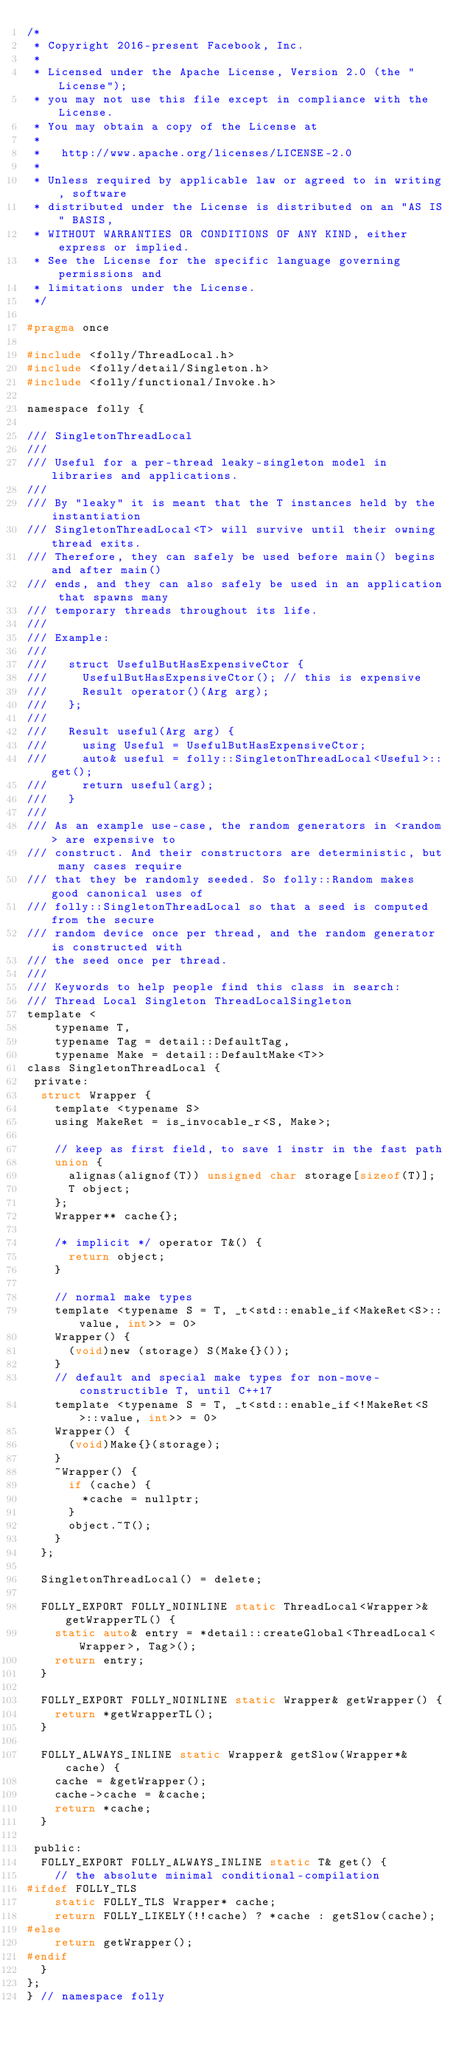Convert code to text. <code><loc_0><loc_0><loc_500><loc_500><_C_>/*
 * Copyright 2016-present Facebook, Inc.
 *
 * Licensed under the Apache License, Version 2.0 (the "License");
 * you may not use this file except in compliance with the License.
 * You may obtain a copy of the License at
 *
 *   http://www.apache.org/licenses/LICENSE-2.0
 *
 * Unless required by applicable law or agreed to in writing, software
 * distributed under the License is distributed on an "AS IS" BASIS,
 * WITHOUT WARRANTIES OR CONDITIONS OF ANY KIND, either express or implied.
 * See the License for the specific language governing permissions and
 * limitations under the License.
 */

#pragma once

#include <folly/ThreadLocal.h>
#include <folly/detail/Singleton.h>
#include <folly/functional/Invoke.h>

namespace folly {

/// SingletonThreadLocal
///
/// Useful for a per-thread leaky-singleton model in libraries and applications.
///
/// By "leaky" it is meant that the T instances held by the instantiation
/// SingletonThreadLocal<T> will survive until their owning thread exits.
/// Therefore, they can safely be used before main() begins and after main()
/// ends, and they can also safely be used in an application that spawns many
/// temporary threads throughout its life.
///
/// Example:
///
///   struct UsefulButHasExpensiveCtor {
///     UsefulButHasExpensiveCtor(); // this is expensive
///     Result operator()(Arg arg);
///   };
///
///   Result useful(Arg arg) {
///     using Useful = UsefulButHasExpensiveCtor;
///     auto& useful = folly::SingletonThreadLocal<Useful>::get();
///     return useful(arg);
///   }
///
/// As an example use-case, the random generators in <random> are expensive to
/// construct. And their constructors are deterministic, but many cases require
/// that they be randomly seeded. So folly::Random makes good canonical uses of
/// folly::SingletonThreadLocal so that a seed is computed from the secure
/// random device once per thread, and the random generator is constructed with
/// the seed once per thread.
///
/// Keywords to help people find this class in search:
/// Thread Local Singleton ThreadLocalSingleton
template <
    typename T,
    typename Tag = detail::DefaultTag,
    typename Make = detail::DefaultMake<T>>
class SingletonThreadLocal {
 private:
  struct Wrapper {
    template <typename S>
    using MakeRet = is_invocable_r<S, Make>;

    // keep as first field, to save 1 instr in the fast path
    union {
      alignas(alignof(T)) unsigned char storage[sizeof(T)];
      T object;
    };
    Wrapper** cache{};

    /* implicit */ operator T&() {
      return object;
    }

    // normal make types
    template <typename S = T, _t<std::enable_if<MakeRet<S>::value, int>> = 0>
    Wrapper() {
      (void)new (storage) S(Make{}());
    }
    // default and special make types for non-move-constructible T, until C++17
    template <typename S = T, _t<std::enable_if<!MakeRet<S>::value, int>> = 0>
    Wrapper() {
      (void)Make{}(storage);
    }
    ~Wrapper() {
      if (cache) {
        *cache = nullptr;
      }
      object.~T();
    }
  };

  SingletonThreadLocal() = delete;

  FOLLY_EXPORT FOLLY_NOINLINE static ThreadLocal<Wrapper>& getWrapperTL() {
    static auto& entry = *detail::createGlobal<ThreadLocal<Wrapper>, Tag>();
    return entry;
  }

  FOLLY_EXPORT FOLLY_NOINLINE static Wrapper& getWrapper() {
    return *getWrapperTL();
  }

  FOLLY_ALWAYS_INLINE static Wrapper& getSlow(Wrapper*& cache) {
    cache = &getWrapper();
    cache->cache = &cache;
    return *cache;
  }

 public:
  FOLLY_EXPORT FOLLY_ALWAYS_INLINE static T& get() {
    // the absolute minimal conditional-compilation
#ifdef FOLLY_TLS
    static FOLLY_TLS Wrapper* cache;
    return FOLLY_LIKELY(!!cache) ? *cache : getSlow(cache);
#else
    return getWrapper();
#endif
  }
};
} // namespace folly
</code> 